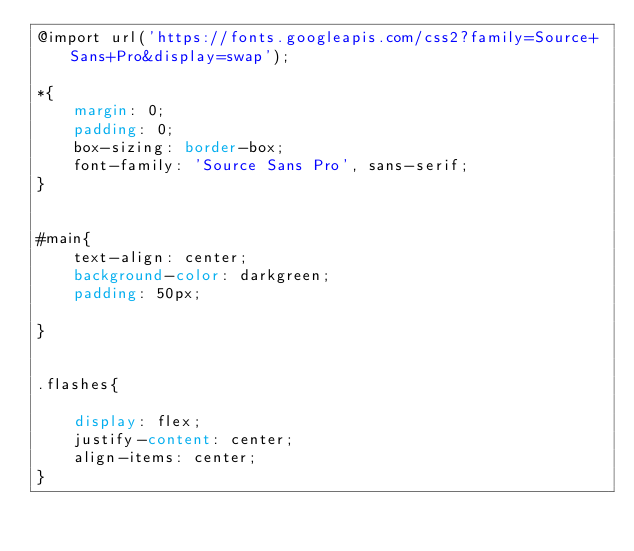Convert code to text. <code><loc_0><loc_0><loc_500><loc_500><_CSS_>@import url('https://fonts.googleapis.com/css2?family=Source+Sans+Pro&display=swap');

*{
    margin: 0;
    padding: 0;
    box-sizing: border-box;
    font-family: 'Source Sans Pro', sans-serif;
}


#main{
    text-align: center;
    background-color: darkgreen;
    padding: 50px;

}


.flashes{
    
    display: flex;
    justify-content: center;
    align-items: center;
}</code> 